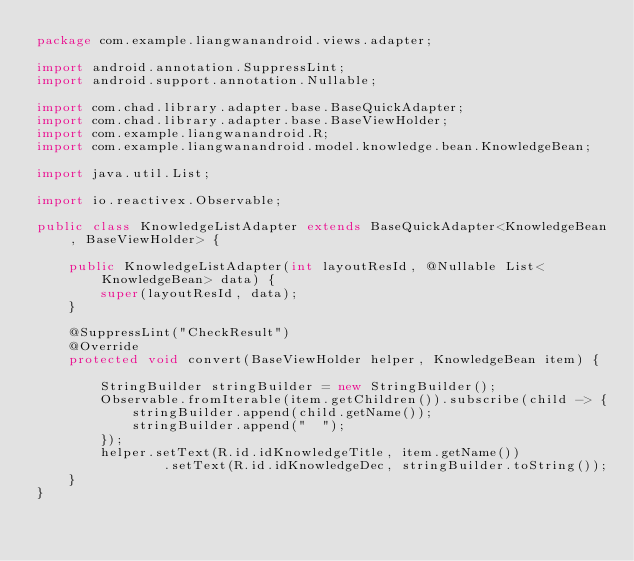<code> <loc_0><loc_0><loc_500><loc_500><_Java_>package com.example.liangwanandroid.views.adapter;

import android.annotation.SuppressLint;
import android.support.annotation.Nullable;

import com.chad.library.adapter.base.BaseQuickAdapter;
import com.chad.library.adapter.base.BaseViewHolder;
import com.example.liangwanandroid.R;
import com.example.liangwanandroid.model.knowledge.bean.KnowledgeBean;

import java.util.List;

import io.reactivex.Observable;

public class KnowledgeListAdapter extends BaseQuickAdapter<KnowledgeBean, BaseViewHolder> {

    public KnowledgeListAdapter(int layoutResId, @Nullable List<KnowledgeBean> data) {
        super(layoutResId, data);
    }

    @SuppressLint("CheckResult")
    @Override
    protected void convert(BaseViewHolder helper, KnowledgeBean item) {

        StringBuilder stringBuilder = new StringBuilder();
        Observable.fromIterable(item.getChildren()).subscribe(child -> {
            stringBuilder.append(child.getName());
            stringBuilder.append("  ");
        });
        helper.setText(R.id.idKnowledgeTitle, item.getName())
                .setText(R.id.idKnowledgeDec, stringBuilder.toString());
    }
}
</code> 